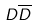Convert formula to latex. <formula><loc_0><loc_0><loc_500><loc_500>D \overline { D }</formula> 